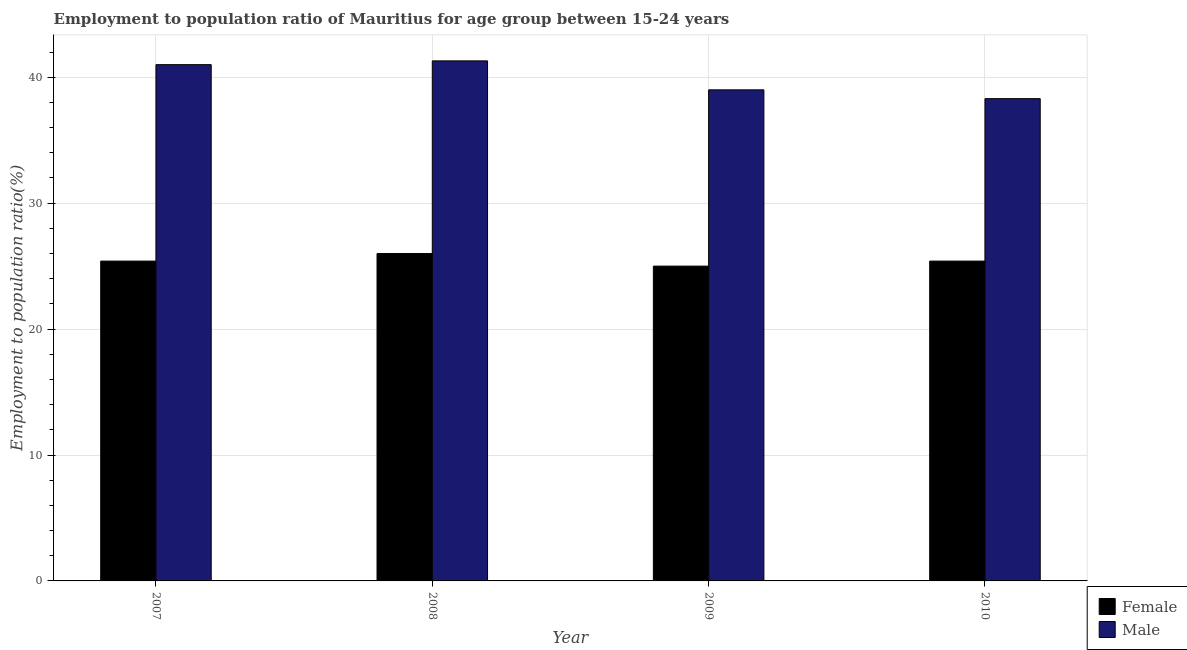How many groups of bars are there?
Your answer should be very brief. 4. Are the number of bars per tick equal to the number of legend labels?
Provide a succinct answer. Yes. How many bars are there on the 1st tick from the left?
Your answer should be very brief. 2. How many bars are there on the 2nd tick from the right?
Ensure brevity in your answer.  2. What is the label of the 4th group of bars from the left?
Your answer should be very brief. 2010. In how many cases, is the number of bars for a given year not equal to the number of legend labels?
Give a very brief answer. 0. What is the employment to population ratio(male) in 2007?
Your answer should be very brief. 41. Across all years, what is the maximum employment to population ratio(male)?
Offer a terse response. 41.3. Across all years, what is the minimum employment to population ratio(female)?
Provide a succinct answer. 25. In which year was the employment to population ratio(male) maximum?
Make the answer very short. 2008. In which year was the employment to population ratio(female) minimum?
Give a very brief answer. 2009. What is the total employment to population ratio(male) in the graph?
Give a very brief answer. 159.6. What is the difference between the employment to population ratio(female) in 2008 and that in 2010?
Offer a terse response. 0.6. What is the difference between the employment to population ratio(male) in 2009 and the employment to population ratio(female) in 2008?
Your answer should be very brief. -2.3. What is the average employment to population ratio(male) per year?
Ensure brevity in your answer.  39.9. What is the ratio of the employment to population ratio(male) in 2007 to that in 2009?
Ensure brevity in your answer.  1.05. What is the difference between the highest and the second highest employment to population ratio(female)?
Offer a very short reply. 0.6. What is the difference between the highest and the lowest employment to population ratio(female)?
Make the answer very short. 1. How many years are there in the graph?
Offer a very short reply. 4. Are the values on the major ticks of Y-axis written in scientific E-notation?
Offer a terse response. No. Does the graph contain any zero values?
Your answer should be compact. No. What is the title of the graph?
Provide a short and direct response. Employment to population ratio of Mauritius for age group between 15-24 years. Does "Revenue" appear as one of the legend labels in the graph?
Offer a very short reply. No. What is the label or title of the X-axis?
Provide a succinct answer. Year. What is the Employment to population ratio(%) in Female in 2007?
Ensure brevity in your answer.  25.4. What is the Employment to population ratio(%) of Female in 2008?
Your response must be concise. 26. What is the Employment to population ratio(%) of Male in 2008?
Your answer should be compact. 41.3. What is the Employment to population ratio(%) of Female in 2010?
Make the answer very short. 25.4. What is the Employment to population ratio(%) of Male in 2010?
Provide a succinct answer. 38.3. Across all years, what is the maximum Employment to population ratio(%) in Male?
Your answer should be compact. 41.3. Across all years, what is the minimum Employment to population ratio(%) in Female?
Ensure brevity in your answer.  25. Across all years, what is the minimum Employment to population ratio(%) of Male?
Make the answer very short. 38.3. What is the total Employment to population ratio(%) in Female in the graph?
Keep it short and to the point. 101.8. What is the total Employment to population ratio(%) in Male in the graph?
Your answer should be compact. 159.6. What is the difference between the Employment to population ratio(%) in Female in 2007 and that in 2008?
Your response must be concise. -0.6. What is the difference between the Employment to population ratio(%) of Male in 2007 and that in 2008?
Keep it short and to the point. -0.3. What is the difference between the Employment to population ratio(%) of Male in 2007 and that in 2009?
Your answer should be very brief. 2. What is the difference between the Employment to population ratio(%) of Male in 2007 and that in 2010?
Provide a succinct answer. 2.7. What is the difference between the Employment to population ratio(%) in Female in 2008 and that in 2009?
Offer a very short reply. 1. What is the difference between the Employment to population ratio(%) in Female in 2009 and that in 2010?
Give a very brief answer. -0.4. What is the difference between the Employment to population ratio(%) of Male in 2009 and that in 2010?
Offer a very short reply. 0.7. What is the difference between the Employment to population ratio(%) in Female in 2007 and the Employment to population ratio(%) in Male in 2008?
Your response must be concise. -15.9. What is the difference between the Employment to population ratio(%) in Female in 2007 and the Employment to population ratio(%) in Male in 2010?
Make the answer very short. -12.9. What is the difference between the Employment to population ratio(%) in Female in 2008 and the Employment to population ratio(%) in Male in 2010?
Provide a short and direct response. -12.3. What is the difference between the Employment to population ratio(%) of Female in 2009 and the Employment to population ratio(%) of Male in 2010?
Your response must be concise. -13.3. What is the average Employment to population ratio(%) of Female per year?
Offer a very short reply. 25.45. What is the average Employment to population ratio(%) in Male per year?
Provide a succinct answer. 39.9. In the year 2007, what is the difference between the Employment to population ratio(%) of Female and Employment to population ratio(%) of Male?
Provide a succinct answer. -15.6. In the year 2008, what is the difference between the Employment to population ratio(%) of Female and Employment to population ratio(%) of Male?
Your answer should be compact. -15.3. What is the ratio of the Employment to population ratio(%) of Female in 2007 to that in 2008?
Offer a terse response. 0.98. What is the ratio of the Employment to population ratio(%) of Male in 2007 to that in 2008?
Your answer should be very brief. 0.99. What is the ratio of the Employment to population ratio(%) of Male in 2007 to that in 2009?
Your response must be concise. 1.05. What is the ratio of the Employment to population ratio(%) of Male in 2007 to that in 2010?
Your answer should be compact. 1.07. What is the ratio of the Employment to population ratio(%) in Male in 2008 to that in 2009?
Provide a succinct answer. 1.06. What is the ratio of the Employment to population ratio(%) of Female in 2008 to that in 2010?
Your answer should be very brief. 1.02. What is the ratio of the Employment to population ratio(%) in Male in 2008 to that in 2010?
Keep it short and to the point. 1.08. What is the ratio of the Employment to population ratio(%) of Female in 2009 to that in 2010?
Offer a terse response. 0.98. What is the ratio of the Employment to population ratio(%) in Male in 2009 to that in 2010?
Give a very brief answer. 1.02. What is the difference between the highest and the second highest Employment to population ratio(%) of Male?
Offer a terse response. 0.3. What is the difference between the highest and the lowest Employment to population ratio(%) of Male?
Offer a terse response. 3. 